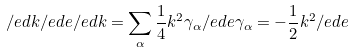<formula> <loc_0><loc_0><loc_500><loc_500>\slash e d { k } \slash e d { e } \slash e d { k } = \sum _ { \alpha } \frac { 1 } { 4 } k ^ { 2 } \gamma _ { \alpha } \slash e d { e } \gamma _ { \alpha } = - \frac { 1 } { 2 } k ^ { 2 } \slash e d { e }</formula> 